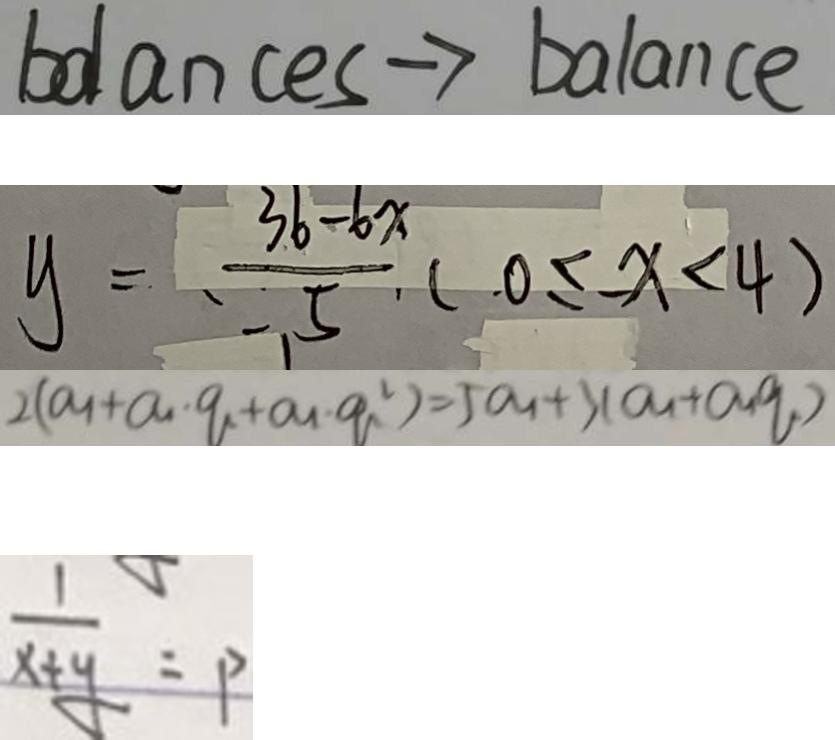Convert formula to latex. <formula><loc_0><loc_0><loc_500><loc_500>b d a n c e s \rightarrow b a l a n c e 
 y = \frac { 3 6 - 6 x } { 5 } ( 0 \leq - x < 4 ) 
 2 ( a _ { 1 } + a _ { 1 } \cdot q + a _ { 1 } \cdot q ^ { 2 } ) = 5 a _ { 1 } + 3 ( a _ { 1 } + a _ { 1 } q ) 
 \frac { 1 } { x + y } = P</formula> 